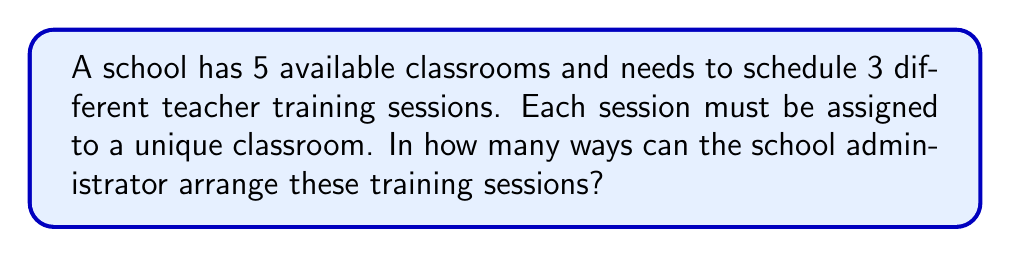Solve this math problem. Let's approach this step-by-step:

1) We have 5 classrooms available and need to choose 3 of them for the training sessions.

2) This is a permutation problem because the order matters (each specific training session is assigned to a specific classroom).

3) We can use the permutation formula:
   
   $P(n,r) = \frac{n!}{(n-r)!}$

   Where $n$ is the total number of items to choose from (classrooms) and $r$ is the number of items being chosen (training sessions).

4) In this case, $n = 5$ and $r = 3$

5) Plugging these values into the formula:

   $P(5,3) = \frac{5!}{(5-3)!} = \frac{5!}{2!}$

6) Expanding this:
   
   $\frac{5 \cdot 4 \cdot 3 \cdot 2!}{2!}$

7) The 2! cancels out in the numerator and denominator:

   $5 \cdot 4 \cdot 3 = 60$

Therefore, there are 60 ways to arrange the 3 training sessions in the 5 classrooms.
Answer: 60 